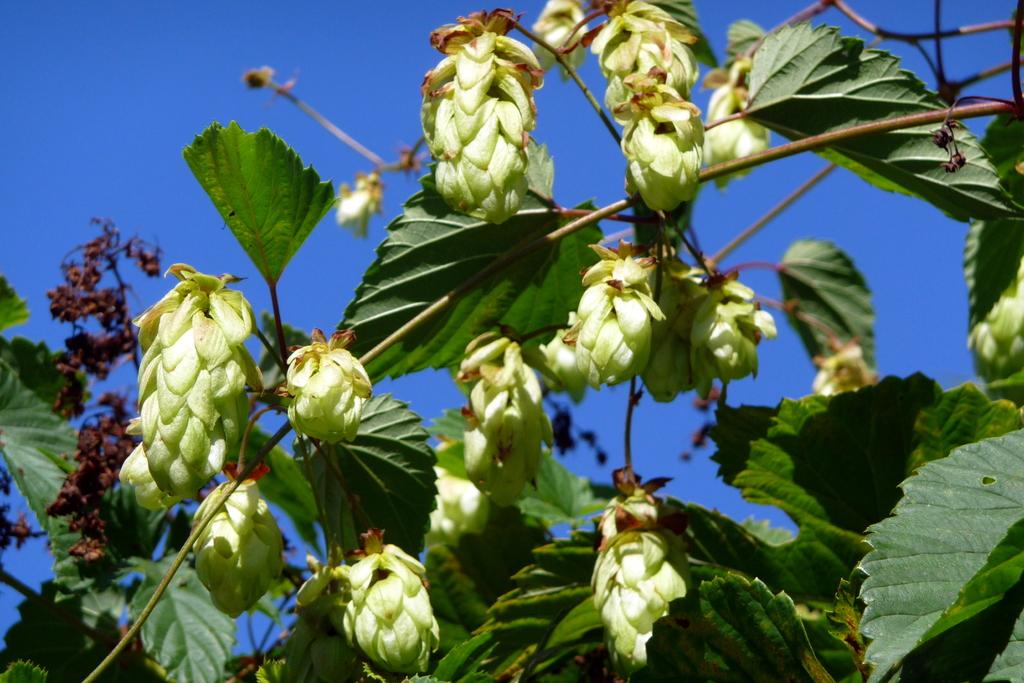What type of living organism is present in the image? There is a plant in the image. What features can be observed on the plant? The plant has leaves, buds, and dried leaves. What is visible in the background of the image? The sky is visible in the background of the image. What color is the sky in the image? The sky is blue in color. Can you hear the dogs barking in the image? There are no dogs present in the image, so it is not possible to hear them barking. 